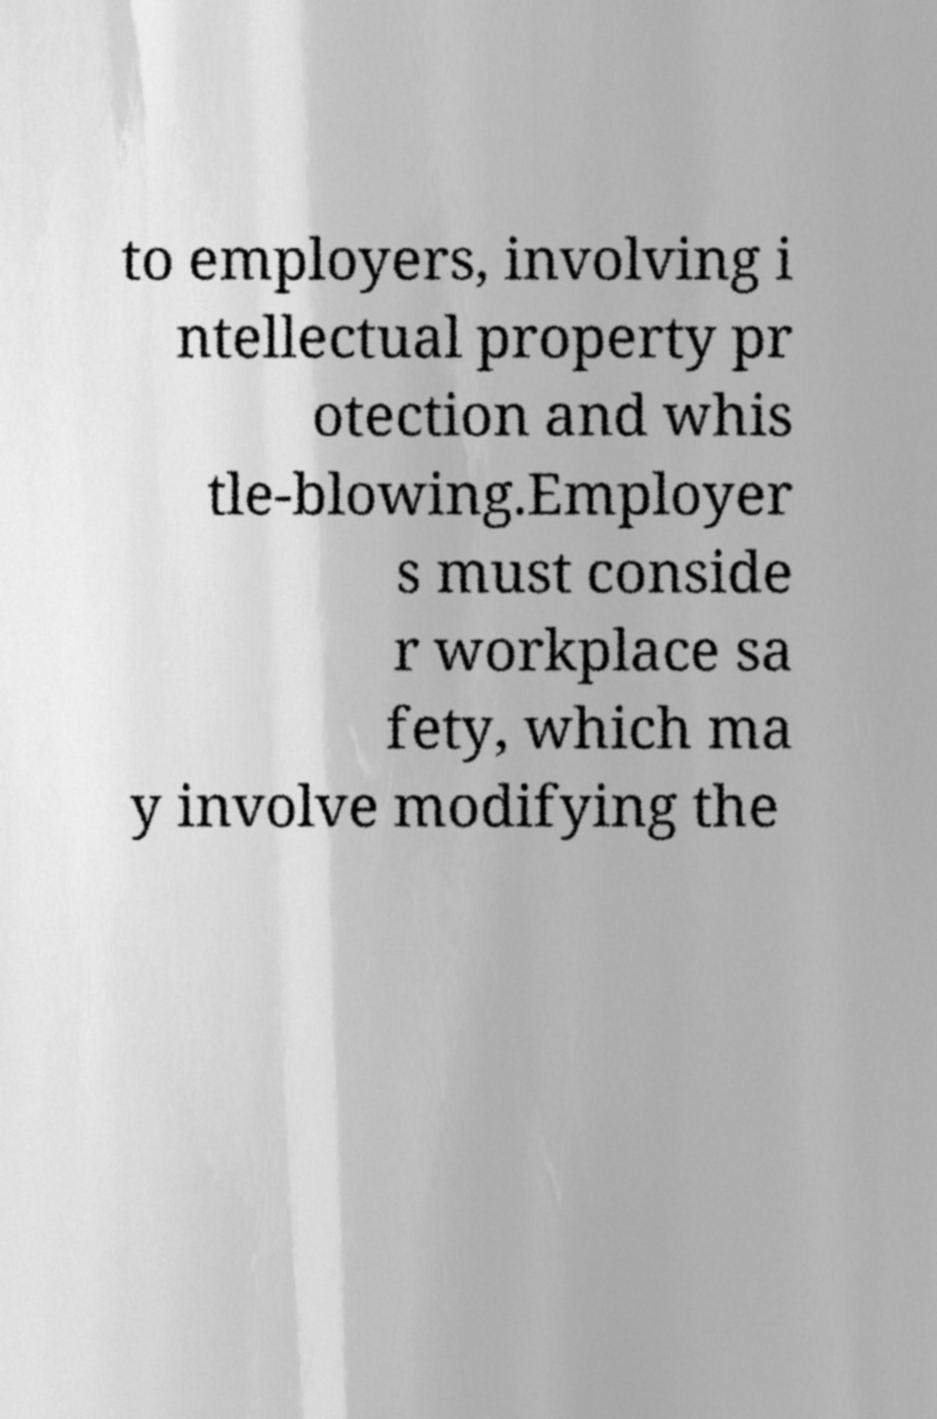Please read and relay the text visible in this image. What does it say? to employers, involving i ntellectual property pr otection and whis tle-blowing.Employer s must conside r workplace sa fety, which ma y involve modifying the 